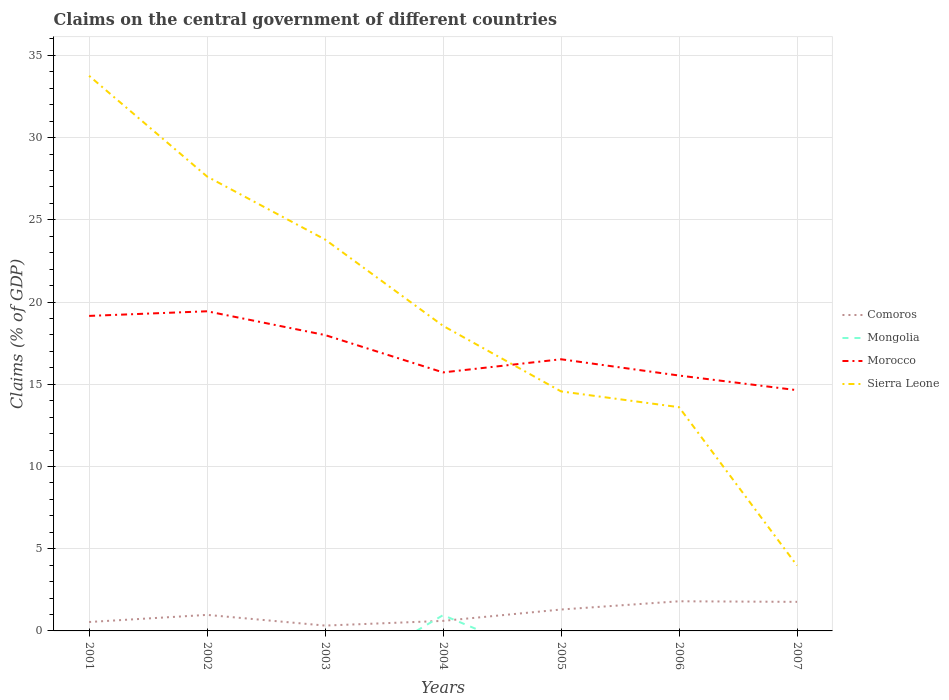Is the number of lines equal to the number of legend labels?
Your response must be concise. No. What is the total percentage of GDP claimed on the central government in Morocco in the graph?
Offer a very short reply. 1.88. What is the difference between the highest and the second highest percentage of GDP claimed on the central government in Morocco?
Make the answer very short. 4.8. What is the difference between the highest and the lowest percentage of GDP claimed on the central government in Morocco?
Offer a terse response. 3. Is the percentage of GDP claimed on the central government in Mongolia strictly greater than the percentage of GDP claimed on the central government in Comoros over the years?
Your answer should be very brief. No. What is the difference between two consecutive major ticks on the Y-axis?
Your response must be concise. 5. Does the graph contain any zero values?
Give a very brief answer. Yes. How many legend labels are there?
Your answer should be very brief. 4. What is the title of the graph?
Offer a very short reply. Claims on the central government of different countries. What is the label or title of the Y-axis?
Offer a very short reply. Claims (% of GDP). What is the Claims (% of GDP) in Comoros in 2001?
Keep it short and to the point. 0.54. What is the Claims (% of GDP) in Mongolia in 2001?
Your answer should be very brief. 0. What is the Claims (% of GDP) in Morocco in 2001?
Your response must be concise. 19.16. What is the Claims (% of GDP) in Sierra Leone in 2001?
Your answer should be very brief. 33.75. What is the Claims (% of GDP) in Comoros in 2002?
Keep it short and to the point. 0.98. What is the Claims (% of GDP) in Morocco in 2002?
Ensure brevity in your answer.  19.44. What is the Claims (% of GDP) of Sierra Leone in 2002?
Your answer should be compact. 27.63. What is the Claims (% of GDP) of Comoros in 2003?
Provide a short and direct response. 0.32. What is the Claims (% of GDP) of Morocco in 2003?
Offer a terse response. 17.99. What is the Claims (% of GDP) of Sierra Leone in 2003?
Offer a terse response. 23.8. What is the Claims (% of GDP) of Comoros in 2004?
Make the answer very short. 0.61. What is the Claims (% of GDP) in Mongolia in 2004?
Your response must be concise. 0.96. What is the Claims (% of GDP) in Morocco in 2004?
Ensure brevity in your answer.  15.72. What is the Claims (% of GDP) in Sierra Leone in 2004?
Make the answer very short. 18.55. What is the Claims (% of GDP) in Comoros in 2005?
Provide a succinct answer. 1.3. What is the Claims (% of GDP) of Morocco in 2005?
Keep it short and to the point. 16.52. What is the Claims (% of GDP) of Sierra Leone in 2005?
Your answer should be very brief. 14.56. What is the Claims (% of GDP) of Comoros in 2006?
Your answer should be very brief. 1.8. What is the Claims (% of GDP) of Morocco in 2006?
Your answer should be compact. 15.53. What is the Claims (% of GDP) of Sierra Leone in 2006?
Your answer should be compact. 13.6. What is the Claims (% of GDP) in Comoros in 2007?
Ensure brevity in your answer.  1.77. What is the Claims (% of GDP) of Mongolia in 2007?
Ensure brevity in your answer.  0. What is the Claims (% of GDP) of Morocco in 2007?
Ensure brevity in your answer.  14.64. What is the Claims (% of GDP) of Sierra Leone in 2007?
Provide a short and direct response. 3.97. Across all years, what is the maximum Claims (% of GDP) in Comoros?
Make the answer very short. 1.8. Across all years, what is the maximum Claims (% of GDP) in Mongolia?
Give a very brief answer. 0.96. Across all years, what is the maximum Claims (% of GDP) of Morocco?
Your answer should be very brief. 19.44. Across all years, what is the maximum Claims (% of GDP) of Sierra Leone?
Your answer should be very brief. 33.75. Across all years, what is the minimum Claims (% of GDP) in Comoros?
Your answer should be compact. 0.32. Across all years, what is the minimum Claims (% of GDP) of Morocco?
Ensure brevity in your answer.  14.64. Across all years, what is the minimum Claims (% of GDP) in Sierra Leone?
Keep it short and to the point. 3.97. What is the total Claims (% of GDP) in Comoros in the graph?
Keep it short and to the point. 7.33. What is the total Claims (% of GDP) of Mongolia in the graph?
Offer a terse response. 0.96. What is the total Claims (% of GDP) of Morocco in the graph?
Offer a very short reply. 118.99. What is the total Claims (% of GDP) of Sierra Leone in the graph?
Offer a terse response. 135.88. What is the difference between the Claims (% of GDP) in Comoros in 2001 and that in 2002?
Ensure brevity in your answer.  -0.43. What is the difference between the Claims (% of GDP) in Morocco in 2001 and that in 2002?
Make the answer very short. -0.28. What is the difference between the Claims (% of GDP) in Sierra Leone in 2001 and that in 2002?
Your response must be concise. 6.13. What is the difference between the Claims (% of GDP) in Comoros in 2001 and that in 2003?
Keep it short and to the point. 0.22. What is the difference between the Claims (% of GDP) in Morocco in 2001 and that in 2003?
Offer a very short reply. 1.16. What is the difference between the Claims (% of GDP) of Sierra Leone in 2001 and that in 2003?
Provide a succinct answer. 9.95. What is the difference between the Claims (% of GDP) in Comoros in 2001 and that in 2004?
Your response must be concise. -0.07. What is the difference between the Claims (% of GDP) of Morocco in 2001 and that in 2004?
Keep it short and to the point. 3.44. What is the difference between the Claims (% of GDP) of Sierra Leone in 2001 and that in 2004?
Give a very brief answer. 15.2. What is the difference between the Claims (% of GDP) in Comoros in 2001 and that in 2005?
Provide a succinct answer. -0.76. What is the difference between the Claims (% of GDP) of Morocco in 2001 and that in 2005?
Provide a succinct answer. 2.64. What is the difference between the Claims (% of GDP) of Sierra Leone in 2001 and that in 2005?
Provide a short and direct response. 19.19. What is the difference between the Claims (% of GDP) in Comoros in 2001 and that in 2006?
Give a very brief answer. -1.26. What is the difference between the Claims (% of GDP) in Morocco in 2001 and that in 2006?
Your answer should be compact. 3.63. What is the difference between the Claims (% of GDP) of Sierra Leone in 2001 and that in 2006?
Your answer should be compact. 20.15. What is the difference between the Claims (% of GDP) of Comoros in 2001 and that in 2007?
Give a very brief answer. -1.23. What is the difference between the Claims (% of GDP) of Morocco in 2001 and that in 2007?
Offer a terse response. 4.52. What is the difference between the Claims (% of GDP) of Sierra Leone in 2001 and that in 2007?
Your answer should be very brief. 29.78. What is the difference between the Claims (% of GDP) of Comoros in 2002 and that in 2003?
Keep it short and to the point. 0.65. What is the difference between the Claims (% of GDP) in Morocco in 2002 and that in 2003?
Your answer should be very brief. 1.45. What is the difference between the Claims (% of GDP) in Sierra Leone in 2002 and that in 2003?
Offer a terse response. 3.83. What is the difference between the Claims (% of GDP) of Comoros in 2002 and that in 2004?
Your response must be concise. 0.36. What is the difference between the Claims (% of GDP) of Morocco in 2002 and that in 2004?
Your answer should be compact. 3.72. What is the difference between the Claims (% of GDP) in Sierra Leone in 2002 and that in 2004?
Provide a succinct answer. 9.08. What is the difference between the Claims (% of GDP) of Comoros in 2002 and that in 2005?
Offer a very short reply. -0.33. What is the difference between the Claims (% of GDP) in Morocco in 2002 and that in 2005?
Ensure brevity in your answer.  2.92. What is the difference between the Claims (% of GDP) of Sierra Leone in 2002 and that in 2005?
Make the answer very short. 13.06. What is the difference between the Claims (% of GDP) of Comoros in 2002 and that in 2006?
Your answer should be very brief. -0.83. What is the difference between the Claims (% of GDP) of Morocco in 2002 and that in 2006?
Provide a succinct answer. 3.91. What is the difference between the Claims (% of GDP) in Sierra Leone in 2002 and that in 2006?
Give a very brief answer. 14.02. What is the difference between the Claims (% of GDP) in Comoros in 2002 and that in 2007?
Keep it short and to the point. -0.79. What is the difference between the Claims (% of GDP) in Morocco in 2002 and that in 2007?
Your answer should be very brief. 4.8. What is the difference between the Claims (% of GDP) in Sierra Leone in 2002 and that in 2007?
Your response must be concise. 23.66. What is the difference between the Claims (% of GDP) of Comoros in 2003 and that in 2004?
Offer a terse response. -0.29. What is the difference between the Claims (% of GDP) of Morocco in 2003 and that in 2004?
Your answer should be very brief. 2.27. What is the difference between the Claims (% of GDP) in Sierra Leone in 2003 and that in 2004?
Keep it short and to the point. 5.25. What is the difference between the Claims (% of GDP) in Comoros in 2003 and that in 2005?
Offer a very short reply. -0.98. What is the difference between the Claims (% of GDP) in Morocco in 2003 and that in 2005?
Provide a succinct answer. 1.47. What is the difference between the Claims (% of GDP) of Sierra Leone in 2003 and that in 2005?
Keep it short and to the point. 9.24. What is the difference between the Claims (% of GDP) of Comoros in 2003 and that in 2006?
Your answer should be very brief. -1.48. What is the difference between the Claims (% of GDP) of Morocco in 2003 and that in 2006?
Provide a succinct answer. 2.46. What is the difference between the Claims (% of GDP) of Sierra Leone in 2003 and that in 2006?
Give a very brief answer. 10.2. What is the difference between the Claims (% of GDP) in Comoros in 2003 and that in 2007?
Your answer should be compact. -1.44. What is the difference between the Claims (% of GDP) of Morocco in 2003 and that in 2007?
Your answer should be compact. 3.35. What is the difference between the Claims (% of GDP) of Sierra Leone in 2003 and that in 2007?
Your response must be concise. 19.83. What is the difference between the Claims (% of GDP) of Comoros in 2004 and that in 2005?
Offer a terse response. -0.69. What is the difference between the Claims (% of GDP) in Morocco in 2004 and that in 2005?
Your answer should be compact. -0.8. What is the difference between the Claims (% of GDP) of Sierra Leone in 2004 and that in 2005?
Your answer should be compact. 3.99. What is the difference between the Claims (% of GDP) of Comoros in 2004 and that in 2006?
Ensure brevity in your answer.  -1.19. What is the difference between the Claims (% of GDP) in Morocco in 2004 and that in 2006?
Provide a short and direct response. 0.19. What is the difference between the Claims (% of GDP) of Sierra Leone in 2004 and that in 2006?
Your answer should be very brief. 4.95. What is the difference between the Claims (% of GDP) in Comoros in 2004 and that in 2007?
Ensure brevity in your answer.  -1.16. What is the difference between the Claims (% of GDP) in Morocco in 2004 and that in 2007?
Your answer should be compact. 1.08. What is the difference between the Claims (% of GDP) of Sierra Leone in 2004 and that in 2007?
Your response must be concise. 14.58. What is the difference between the Claims (% of GDP) of Comoros in 2005 and that in 2006?
Offer a terse response. -0.5. What is the difference between the Claims (% of GDP) of Morocco in 2005 and that in 2006?
Offer a very short reply. 0.99. What is the difference between the Claims (% of GDP) of Sierra Leone in 2005 and that in 2006?
Give a very brief answer. 0.96. What is the difference between the Claims (% of GDP) of Comoros in 2005 and that in 2007?
Keep it short and to the point. -0.47. What is the difference between the Claims (% of GDP) in Morocco in 2005 and that in 2007?
Offer a terse response. 1.88. What is the difference between the Claims (% of GDP) in Sierra Leone in 2005 and that in 2007?
Provide a succinct answer. 10.59. What is the difference between the Claims (% of GDP) of Comoros in 2006 and that in 2007?
Give a very brief answer. 0.04. What is the difference between the Claims (% of GDP) of Morocco in 2006 and that in 2007?
Offer a very short reply. 0.89. What is the difference between the Claims (% of GDP) in Sierra Leone in 2006 and that in 2007?
Provide a short and direct response. 9.63. What is the difference between the Claims (% of GDP) in Comoros in 2001 and the Claims (% of GDP) in Morocco in 2002?
Ensure brevity in your answer.  -18.89. What is the difference between the Claims (% of GDP) of Comoros in 2001 and the Claims (% of GDP) of Sierra Leone in 2002?
Offer a terse response. -27.09. What is the difference between the Claims (% of GDP) in Morocco in 2001 and the Claims (% of GDP) in Sierra Leone in 2002?
Your answer should be compact. -8.47. What is the difference between the Claims (% of GDP) in Comoros in 2001 and the Claims (% of GDP) in Morocco in 2003?
Provide a short and direct response. -17.45. What is the difference between the Claims (% of GDP) in Comoros in 2001 and the Claims (% of GDP) in Sierra Leone in 2003?
Provide a short and direct response. -23.26. What is the difference between the Claims (% of GDP) in Morocco in 2001 and the Claims (% of GDP) in Sierra Leone in 2003?
Provide a short and direct response. -4.64. What is the difference between the Claims (% of GDP) of Comoros in 2001 and the Claims (% of GDP) of Mongolia in 2004?
Offer a terse response. -0.42. What is the difference between the Claims (% of GDP) of Comoros in 2001 and the Claims (% of GDP) of Morocco in 2004?
Your answer should be compact. -15.18. What is the difference between the Claims (% of GDP) of Comoros in 2001 and the Claims (% of GDP) of Sierra Leone in 2004?
Make the answer very short. -18.01. What is the difference between the Claims (% of GDP) in Morocco in 2001 and the Claims (% of GDP) in Sierra Leone in 2004?
Your answer should be compact. 0.6. What is the difference between the Claims (% of GDP) in Comoros in 2001 and the Claims (% of GDP) in Morocco in 2005?
Provide a short and direct response. -15.98. What is the difference between the Claims (% of GDP) in Comoros in 2001 and the Claims (% of GDP) in Sierra Leone in 2005?
Your answer should be very brief. -14.02. What is the difference between the Claims (% of GDP) of Morocco in 2001 and the Claims (% of GDP) of Sierra Leone in 2005?
Your response must be concise. 4.59. What is the difference between the Claims (% of GDP) in Comoros in 2001 and the Claims (% of GDP) in Morocco in 2006?
Make the answer very short. -14.99. What is the difference between the Claims (% of GDP) of Comoros in 2001 and the Claims (% of GDP) of Sierra Leone in 2006?
Offer a very short reply. -13.06. What is the difference between the Claims (% of GDP) in Morocco in 2001 and the Claims (% of GDP) in Sierra Leone in 2006?
Your answer should be compact. 5.55. What is the difference between the Claims (% of GDP) of Comoros in 2001 and the Claims (% of GDP) of Morocco in 2007?
Offer a terse response. -14.1. What is the difference between the Claims (% of GDP) in Comoros in 2001 and the Claims (% of GDP) in Sierra Leone in 2007?
Make the answer very short. -3.43. What is the difference between the Claims (% of GDP) of Morocco in 2001 and the Claims (% of GDP) of Sierra Leone in 2007?
Ensure brevity in your answer.  15.18. What is the difference between the Claims (% of GDP) in Comoros in 2002 and the Claims (% of GDP) in Morocco in 2003?
Your answer should be compact. -17.01. What is the difference between the Claims (% of GDP) in Comoros in 2002 and the Claims (% of GDP) in Sierra Leone in 2003?
Your response must be concise. -22.82. What is the difference between the Claims (% of GDP) of Morocco in 2002 and the Claims (% of GDP) of Sierra Leone in 2003?
Offer a very short reply. -4.36. What is the difference between the Claims (% of GDP) in Comoros in 2002 and the Claims (% of GDP) in Mongolia in 2004?
Your response must be concise. 0.02. What is the difference between the Claims (% of GDP) in Comoros in 2002 and the Claims (% of GDP) in Morocco in 2004?
Provide a succinct answer. -14.74. What is the difference between the Claims (% of GDP) of Comoros in 2002 and the Claims (% of GDP) of Sierra Leone in 2004?
Your answer should be very brief. -17.58. What is the difference between the Claims (% of GDP) in Morocco in 2002 and the Claims (% of GDP) in Sierra Leone in 2004?
Make the answer very short. 0.89. What is the difference between the Claims (% of GDP) of Comoros in 2002 and the Claims (% of GDP) of Morocco in 2005?
Your answer should be very brief. -15.54. What is the difference between the Claims (% of GDP) of Comoros in 2002 and the Claims (% of GDP) of Sierra Leone in 2005?
Offer a very short reply. -13.59. What is the difference between the Claims (% of GDP) of Morocco in 2002 and the Claims (% of GDP) of Sierra Leone in 2005?
Ensure brevity in your answer.  4.87. What is the difference between the Claims (% of GDP) of Comoros in 2002 and the Claims (% of GDP) of Morocco in 2006?
Provide a succinct answer. -14.55. What is the difference between the Claims (% of GDP) in Comoros in 2002 and the Claims (% of GDP) in Sierra Leone in 2006?
Your answer should be very brief. -12.63. What is the difference between the Claims (% of GDP) of Morocco in 2002 and the Claims (% of GDP) of Sierra Leone in 2006?
Provide a short and direct response. 5.83. What is the difference between the Claims (% of GDP) of Comoros in 2002 and the Claims (% of GDP) of Morocco in 2007?
Your answer should be compact. -13.66. What is the difference between the Claims (% of GDP) of Comoros in 2002 and the Claims (% of GDP) of Sierra Leone in 2007?
Offer a terse response. -3. What is the difference between the Claims (% of GDP) in Morocco in 2002 and the Claims (% of GDP) in Sierra Leone in 2007?
Ensure brevity in your answer.  15.46. What is the difference between the Claims (% of GDP) of Comoros in 2003 and the Claims (% of GDP) of Mongolia in 2004?
Your answer should be compact. -0.63. What is the difference between the Claims (% of GDP) in Comoros in 2003 and the Claims (% of GDP) in Morocco in 2004?
Your response must be concise. -15.39. What is the difference between the Claims (% of GDP) of Comoros in 2003 and the Claims (% of GDP) of Sierra Leone in 2004?
Your answer should be very brief. -18.23. What is the difference between the Claims (% of GDP) of Morocco in 2003 and the Claims (% of GDP) of Sierra Leone in 2004?
Provide a succinct answer. -0.56. What is the difference between the Claims (% of GDP) in Comoros in 2003 and the Claims (% of GDP) in Morocco in 2005?
Your response must be concise. -16.19. What is the difference between the Claims (% of GDP) of Comoros in 2003 and the Claims (% of GDP) of Sierra Leone in 2005?
Provide a short and direct response. -14.24. What is the difference between the Claims (% of GDP) in Morocco in 2003 and the Claims (% of GDP) in Sierra Leone in 2005?
Your answer should be compact. 3.43. What is the difference between the Claims (% of GDP) of Comoros in 2003 and the Claims (% of GDP) of Morocco in 2006?
Provide a succinct answer. -15.2. What is the difference between the Claims (% of GDP) in Comoros in 2003 and the Claims (% of GDP) in Sierra Leone in 2006?
Your response must be concise. -13.28. What is the difference between the Claims (% of GDP) in Morocco in 2003 and the Claims (% of GDP) in Sierra Leone in 2006?
Offer a very short reply. 4.39. What is the difference between the Claims (% of GDP) in Comoros in 2003 and the Claims (% of GDP) in Morocco in 2007?
Ensure brevity in your answer.  -14.31. What is the difference between the Claims (% of GDP) in Comoros in 2003 and the Claims (% of GDP) in Sierra Leone in 2007?
Your response must be concise. -3.65. What is the difference between the Claims (% of GDP) in Morocco in 2003 and the Claims (% of GDP) in Sierra Leone in 2007?
Offer a terse response. 14.02. What is the difference between the Claims (% of GDP) in Comoros in 2004 and the Claims (% of GDP) in Morocco in 2005?
Your answer should be very brief. -15.91. What is the difference between the Claims (% of GDP) of Comoros in 2004 and the Claims (% of GDP) of Sierra Leone in 2005?
Your answer should be very brief. -13.95. What is the difference between the Claims (% of GDP) of Mongolia in 2004 and the Claims (% of GDP) of Morocco in 2005?
Offer a very short reply. -15.56. What is the difference between the Claims (% of GDP) of Mongolia in 2004 and the Claims (% of GDP) of Sierra Leone in 2005?
Offer a very short reply. -13.61. What is the difference between the Claims (% of GDP) in Morocco in 2004 and the Claims (% of GDP) in Sierra Leone in 2005?
Offer a terse response. 1.16. What is the difference between the Claims (% of GDP) of Comoros in 2004 and the Claims (% of GDP) of Morocco in 2006?
Keep it short and to the point. -14.92. What is the difference between the Claims (% of GDP) of Comoros in 2004 and the Claims (% of GDP) of Sierra Leone in 2006?
Make the answer very short. -12.99. What is the difference between the Claims (% of GDP) of Mongolia in 2004 and the Claims (% of GDP) of Morocco in 2006?
Keep it short and to the point. -14.57. What is the difference between the Claims (% of GDP) in Mongolia in 2004 and the Claims (% of GDP) in Sierra Leone in 2006?
Provide a succinct answer. -12.65. What is the difference between the Claims (% of GDP) in Morocco in 2004 and the Claims (% of GDP) in Sierra Leone in 2006?
Your response must be concise. 2.12. What is the difference between the Claims (% of GDP) in Comoros in 2004 and the Claims (% of GDP) in Morocco in 2007?
Keep it short and to the point. -14.03. What is the difference between the Claims (% of GDP) of Comoros in 2004 and the Claims (% of GDP) of Sierra Leone in 2007?
Provide a succinct answer. -3.36. What is the difference between the Claims (% of GDP) in Mongolia in 2004 and the Claims (% of GDP) in Morocco in 2007?
Provide a short and direct response. -13.68. What is the difference between the Claims (% of GDP) of Mongolia in 2004 and the Claims (% of GDP) of Sierra Leone in 2007?
Your response must be concise. -3.01. What is the difference between the Claims (% of GDP) in Morocco in 2004 and the Claims (% of GDP) in Sierra Leone in 2007?
Your response must be concise. 11.75. What is the difference between the Claims (% of GDP) of Comoros in 2005 and the Claims (% of GDP) of Morocco in 2006?
Provide a short and direct response. -14.23. What is the difference between the Claims (% of GDP) of Comoros in 2005 and the Claims (% of GDP) of Sierra Leone in 2006?
Keep it short and to the point. -12.3. What is the difference between the Claims (% of GDP) in Morocco in 2005 and the Claims (% of GDP) in Sierra Leone in 2006?
Provide a short and direct response. 2.91. What is the difference between the Claims (% of GDP) in Comoros in 2005 and the Claims (% of GDP) in Morocco in 2007?
Your answer should be very brief. -13.34. What is the difference between the Claims (% of GDP) of Comoros in 2005 and the Claims (% of GDP) of Sierra Leone in 2007?
Give a very brief answer. -2.67. What is the difference between the Claims (% of GDP) in Morocco in 2005 and the Claims (% of GDP) in Sierra Leone in 2007?
Ensure brevity in your answer.  12.55. What is the difference between the Claims (% of GDP) in Comoros in 2006 and the Claims (% of GDP) in Morocco in 2007?
Offer a terse response. -12.84. What is the difference between the Claims (% of GDP) of Comoros in 2006 and the Claims (% of GDP) of Sierra Leone in 2007?
Your answer should be very brief. -2.17. What is the difference between the Claims (% of GDP) of Morocco in 2006 and the Claims (% of GDP) of Sierra Leone in 2007?
Make the answer very short. 11.56. What is the average Claims (% of GDP) in Comoros per year?
Offer a very short reply. 1.05. What is the average Claims (% of GDP) of Mongolia per year?
Keep it short and to the point. 0.14. What is the average Claims (% of GDP) of Morocco per year?
Provide a short and direct response. 17. What is the average Claims (% of GDP) of Sierra Leone per year?
Your answer should be compact. 19.41. In the year 2001, what is the difference between the Claims (% of GDP) of Comoros and Claims (% of GDP) of Morocco?
Provide a short and direct response. -18.61. In the year 2001, what is the difference between the Claims (% of GDP) in Comoros and Claims (% of GDP) in Sierra Leone?
Keep it short and to the point. -33.21. In the year 2001, what is the difference between the Claims (% of GDP) of Morocco and Claims (% of GDP) of Sierra Leone?
Offer a terse response. -14.6. In the year 2002, what is the difference between the Claims (% of GDP) in Comoros and Claims (% of GDP) in Morocco?
Give a very brief answer. -18.46. In the year 2002, what is the difference between the Claims (% of GDP) of Comoros and Claims (% of GDP) of Sierra Leone?
Offer a terse response. -26.65. In the year 2002, what is the difference between the Claims (% of GDP) in Morocco and Claims (% of GDP) in Sierra Leone?
Ensure brevity in your answer.  -8.19. In the year 2003, what is the difference between the Claims (% of GDP) of Comoros and Claims (% of GDP) of Morocco?
Provide a short and direct response. -17.67. In the year 2003, what is the difference between the Claims (% of GDP) in Comoros and Claims (% of GDP) in Sierra Leone?
Offer a terse response. -23.48. In the year 2003, what is the difference between the Claims (% of GDP) in Morocco and Claims (% of GDP) in Sierra Leone?
Give a very brief answer. -5.81. In the year 2004, what is the difference between the Claims (% of GDP) of Comoros and Claims (% of GDP) of Mongolia?
Offer a very short reply. -0.35. In the year 2004, what is the difference between the Claims (% of GDP) of Comoros and Claims (% of GDP) of Morocco?
Your answer should be compact. -15.11. In the year 2004, what is the difference between the Claims (% of GDP) in Comoros and Claims (% of GDP) in Sierra Leone?
Your response must be concise. -17.94. In the year 2004, what is the difference between the Claims (% of GDP) of Mongolia and Claims (% of GDP) of Morocco?
Your answer should be compact. -14.76. In the year 2004, what is the difference between the Claims (% of GDP) of Mongolia and Claims (% of GDP) of Sierra Leone?
Provide a succinct answer. -17.59. In the year 2004, what is the difference between the Claims (% of GDP) of Morocco and Claims (% of GDP) of Sierra Leone?
Provide a succinct answer. -2.83. In the year 2005, what is the difference between the Claims (% of GDP) of Comoros and Claims (% of GDP) of Morocco?
Offer a terse response. -15.22. In the year 2005, what is the difference between the Claims (% of GDP) of Comoros and Claims (% of GDP) of Sierra Leone?
Keep it short and to the point. -13.26. In the year 2005, what is the difference between the Claims (% of GDP) of Morocco and Claims (% of GDP) of Sierra Leone?
Ensure brevity in your answer.  1.95. In the year 2006, what is the difference between the Claims (% of GDP) of Comoros and Claims (% of GDP) of Morocco?
Ensure brevity in your answer.  -13.73. In the year 2006, what is the difference between the Claims (% of GDP) of Comoros and Claims (% of GDP) of Sierra Leone?
Make the answer very short. -11.8. In the year 2006, what is the difference between the Claims (% of GDP) of Morocco and Claims (% of GDP) of Sierra Leone?
Provide a succinct answer. 1.92. In the year 2007, what is the difference between the Claims (% of GDP) in Comoros and Claims (% of GDP) in Morocco?
Keep it short and to the point. -12.87. In the year 2007, what is the difference between the Claims (% of GDP) of Comoros and Claims (% of GDP) of Sierra Leone?
Give a very brief answer. -2.21. In the year 2007, what is the difference between the Claims (% of GDP) of Morocco and Claims (% of GDP) of Sierra Leone?
Provide a succinct answer. 10.67. What is the ratio of the Claims (% of GDP) of Comoros in 2001 to that in 2002?
Provide a succinct answer. 0.56. What is the ratio of the Claims (% of GDP) of Morocco in 2001 to that in 2002?
Ensure brevity in your answer.  0.99. What is the ratio of the Claims (% of GDP) of Sierra Leone in 2001 to that in 2002?
Your answer should be compact. 1.22. What is the ratio of the Claims (% of GDP) of Comoros in 2001 to that in 2003?
Keep it short and to the point. 1.67. What is the ratio of the Claims (% of GDP) of Morocco in 2001 to that in 2003?
Your response must be concise. 1.06. What is the ratio of the Claims (% of GDP) of Sierra Leone in 2001 to that in 2003?
Provide a short and direct response. 1.42. What is the ratio of the Claims (% of GDP) in Comoros in 2001 to that in 2004?
Provide a succinct answer. 0.89. What is the ratio of the Claims (% of GDP) of Morocco in 2001 to that in 2004?
Your response must be concise. 1.22. What is the ratio of the Claims (% of GDP) in Sierra Leone in 2001 to that in 2004?
Ensure brevity in your answer.  1.82. What is the ratio of the Claims (% of GDP) in Comoros in 2001 to that in 2005?
Your answer should be very brief. 0.42. What is the ratio of the Claims (% of GDP) of Morocco in 2001 to that in 2005?
Offer a terse response. 1.16. What is the ratio of the Claims (% of GDP) of Sierra Leone in 2001 to that in 2005?
Make the answer very short. 2.32. What is the ratio of the Claims (% of GDP) in Comoros in 2001 to that in 2006?
Keep it short and to the point. 0.3. What is the ratio of the Claims (% of GDP) in Morocco in 2001 to that in 2006?
Provide a succinct answer. 1.23. What is the ratio of the Claims (% of GDP) in Sierra Leone in 2001 to that in 2006?
Provide a succinct answer. 2.48. What is the ratio of the Claims (% of GDP) in Comoros in 2001 to that in 2007?
Provide a short and direct response. 0.31. What is the ratio of the Claims (% of GDP) in Morocco in 2001 to that in 2007?
Provide a short and direct response. 1.31. What is the ratio of the Claims (% of GDP) in Sierra Leone in 2001 to that in 2007?
Provide a short and direct response. 8.5. What is the ratio of the Claims (% of GDP) of Comoros in 2002 to that in 2003?
Offer a very short reply. 3. What is the ratio of the Claims (% of GDP) in Morocco in 2002 to that in 2003?
Your response must be concise. 1.08. What is the ratio of the Claims (% of GDP) in Sierra Leone in 2002 to that in 2003?
Your answer should be very brief. 1.16. What is the ratio of the Claims (% of GDP) of Comoros in 2002 to that in 2004?
Provide a succinct answer. 1.6. What is the ratio of the Claims (% of GDP) in Morocco in 2002 to that in 2004?
Make the answer very short. 1.24. What is the ratio of the Claims (% of GDP) of Sierra Leone in 2002 to that in 2004?
Ensure brevity in your answer.  1.49. What is the ratio of the Claims (% of GDP) of Comoros in 2002 to that in 2005?
Give a very brief answer. 0.75. What is the ratio of the Claims (% of GDP) in Morocco in 2002 to that in 2005?
Your answer should be compact. 1.18. What is the ratio of the Claims (% of GDP) of Sierra Leone in 2002 to that in 2005?
Your response must be concise. 1.9. What is the ratio of the Claims (% of GDP) of Comoros in 2002 to that in 2006?
Your answer should be compact. 0.54. What is the ratio of the Claims (% of GDP) of Morocco in 2002 to that in 2006?
Ensure brevity in your answer.  1.25. What is the ratio of the Claims (% of GDP) of Sierra Leone in 2002 to that in 2006?
Your response must be concise. 2.03. What is the ratio of the Claims (% of GDP) in Comoros in 2002 to that in 2007?
Provide a succinct answer. 0.55. What is the ratio of the Claims (% of GDP) of Morocco in 2002 to that in 2007?
Make the answer very short. 1.33. What is the ratio of the Claims (% of GDP) in Sierra Leone in 2002 to that in 2007?
Keep it short and to the point. 6.95. What is the ratio of the Claims (% of GDP) in Comoros in 2003 to that in 2004?
Offer a terse response. 0.53. What is the ratio of the Claims (% of GDP) of Morocco in 2003 to that in 2004?
Ensure brevity in your answer.  1.14. What is the ratio of the Claims (% of GDP) in Sierra Leone in 2003 to that in 2004?
Your answer should be compact. 1.28. What is the ratio of the Claims (% of GDP) of Comoros in 2003 to that in 2005?
Provide a succinct answer. 0.25. What is the ratio of the Claims (% of GDP) in Morocco in 2003 to that in 2005?
Your answer should be compact. 1.09. What is the ratio of the Claims (% of GDP) of Sierra Leone in 2003 to that in 2005?
Offer a terse response. 1.63. What is the ratio of the Claims (% of GDP) in Comoros in 2003 to that in 2006?
Offer a very short reply. 0.18. What is the ratio of the Claims (% of GDP) in Morocco in 2003 to that in 2006?
Ensure brevity in your answer.  1.16. What is the ratio of the Claims (% of GDP) in Sierra Leone in 2003 to that in 2006?
Offer a terse response. 1.75. What is the ratio of the Claims (% of GDP) in Comoros in 2003 to that in 2007?
Offer a very short reply. 0.18. What is the ratio of the Claims (% of GDP) in Morocco in 2003 to that in 2007?
Your answer should be compact. 1.23. What is the ratio of the Claims (% of GDP) of Sierra Leone in 2003 to that in 2007?
Your answer should be compact. 5.99. What is the ratio of the Claims (% of GDP) in Comoros in 2004 to that in 2005?
Your answer should be compact. 0.47. What is the ratio of the Claims (% of GDP) of Morocco in 2004 to that in 2005?
Ensure brevity in your answer.  0.95. What is the ratio of the Claims (% of GDP) of Sierra Leone in 2004 to that in 2005?
Your answer should be very brief. 1.27. What is the ratio of the Claims (% of GDP) of Comoros in 2004 to that in 2006?
Provide a succinct answer. 0.34. What is the ratio of the Claims (% of GDP) in Morocco in 2004 to that in 2006?
Ensure brevity in your answer.  1.01. What is the ratio of the Claims (% of GDP) in Sierra Leone in 2004 to that in 2006?
Provide a succinct answer. 1.36. What is the ratio of the Claims (% of GDP) in Comoros in 2004 to that in 2007?
Offer a very short reply. 0.35. What is the ratio of the Claims (% of GDP) in Morocco in 2004 to that in 2007?
Offer a very short reply. 1.07. What is the ratio of the Claims (% of GDP) in Sierra Leone in 2004 to that in 2007?
Provide a short and direct response. 4.67. What is the ratio of the Claims (% of GDP) of Comoros in 2005 to that in 2006?
Make the answer very short. 0.72. What is the ratio of the Claims (% of GDP) of Morocco in 2005 to that in 2006?
Give a very brief answer. 1.06. What is the ratio of the Claims (% of GDP) of Sierra Leone in 2005 to that in 2006?
Keep it short and to the point. 1.07. What is the ratio of the Claims (% of GDP) in Comoros in 2005 to that in 2007?
Your answer should be very brief. 0.74. What is the ratio of the Claims (% of GDP) of Morocco in 2005 to that in 2007?
Offer a terse response. 1.13. What is the ratio of the Claims (% of GDP) in Sierra Leone in 2005 to that in 2007?
Offer a very short reply. 3.67. What is the ratio of the Claims (% of GDP) of Comoros in 2006 to that in 2007?
Your answer should be compact. 1.02. What is the ratio of the Claims (% of GDP) of Morocco in 2006 to that in 2007?
Your answer should be compact. 1.06. What is the ratio of the Claims (% of GDP) in Sierra Leone in 2006 to that in 2007?
Provide a succinct answer. 3.42. What is the difference between the highest and the second highest Claims (% of GDP) of Comoros?
Ensure brevity in your answer.  0.04. What is the difference between the highest and the second highest Claims (% of GDP) of Morocco?
Make the answer very short. 0.28. What is the difference between the highest and the second highest Claims (% of GDP) of Sierra Leone?
Your answer should be very brief. 6.13. What is the difference between the highest and the lowest Claims (% of GDP) of Comoros?
Your response must be concise. 1.48. What is the difference between the highest and the lowest Claims (% of GDP) in Morocco?
Give a very brief answer. 4.8. What is the difference between the highest and the lowest Claims (% of GDP) of Sierra Leone?
Your response must be concise. 29.78. 